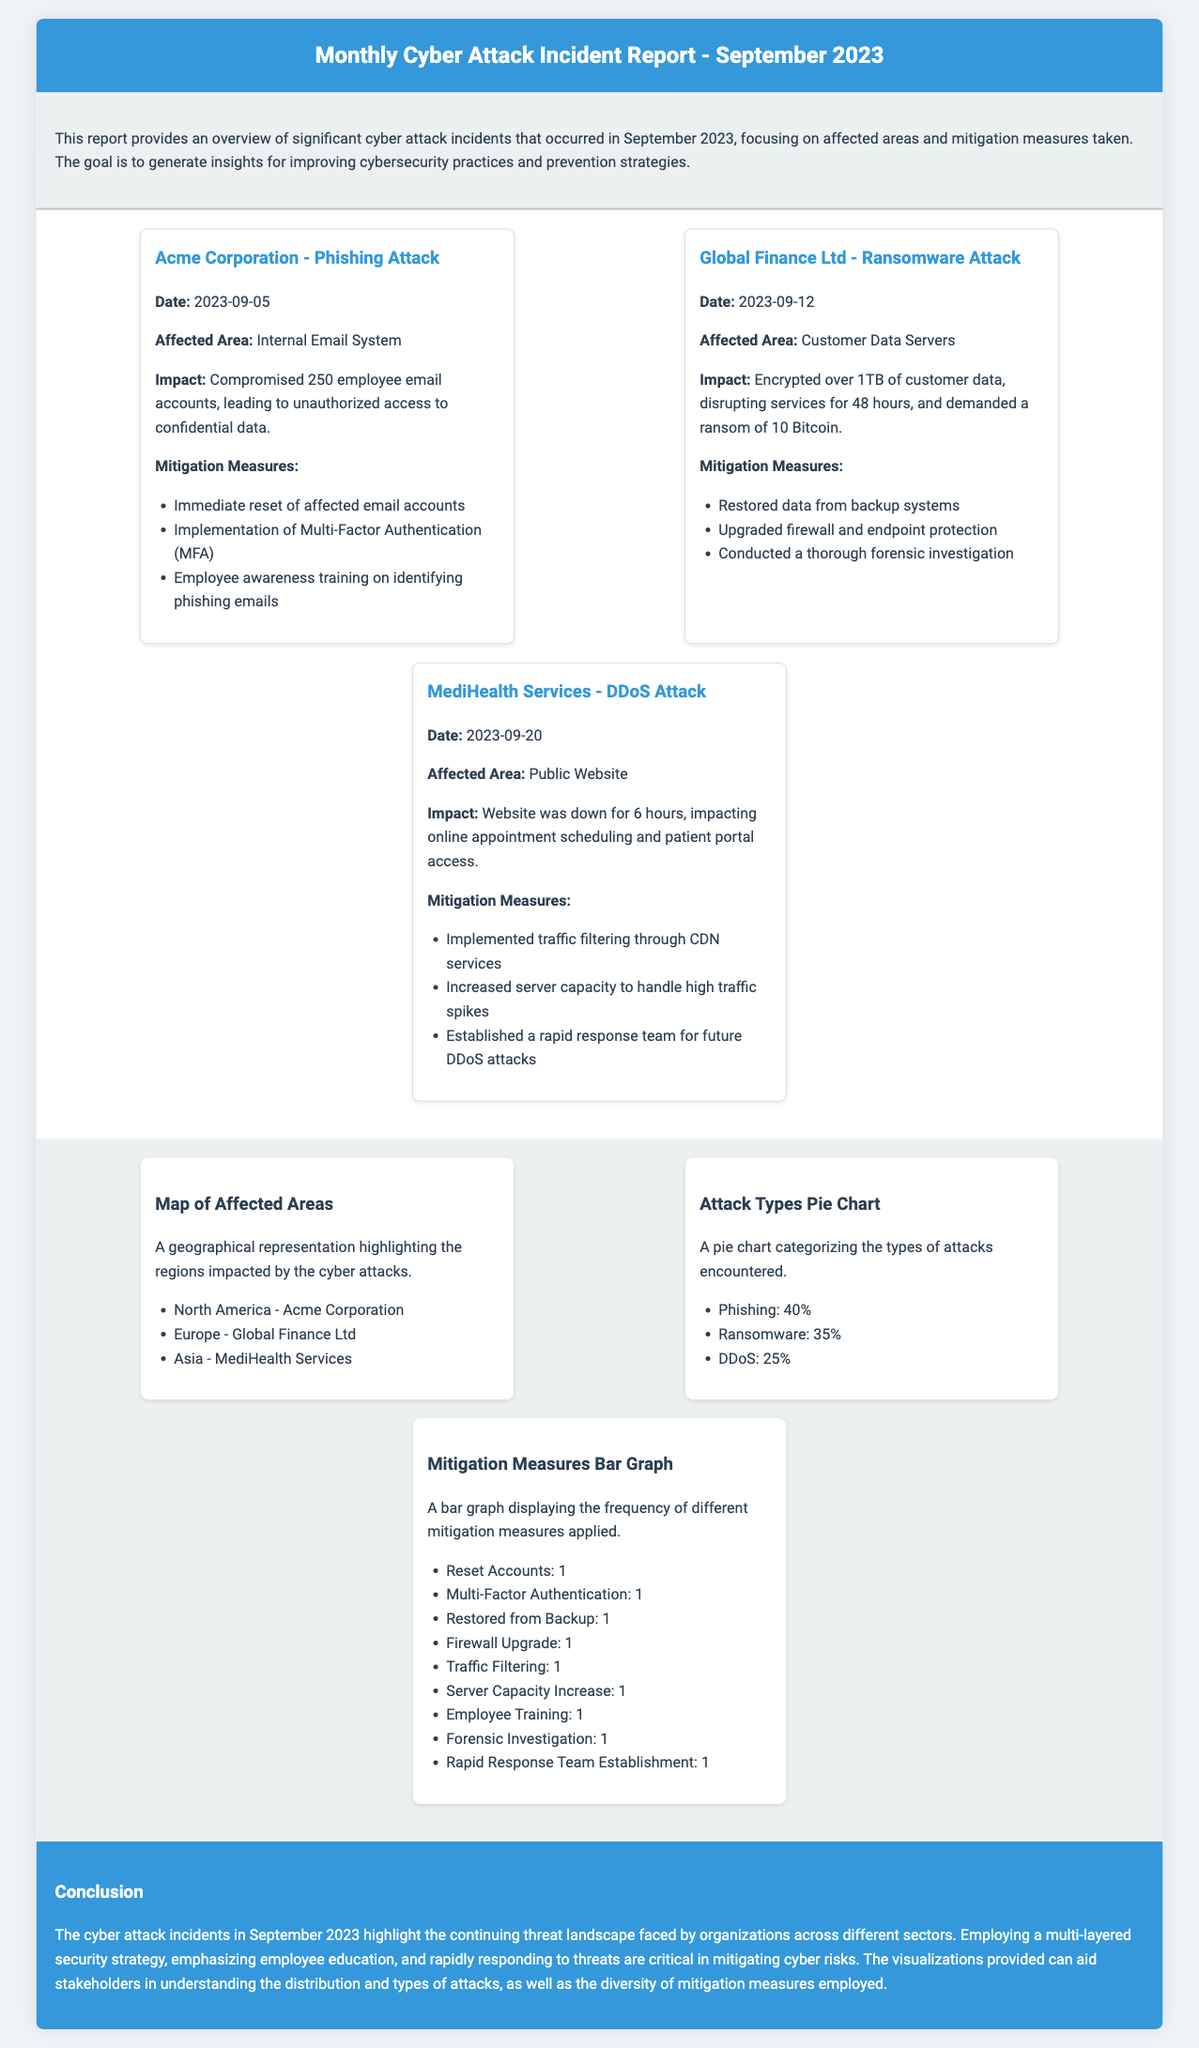What was the date of the phishing attack? The phishing attack occurred on September 5, 2023, as mentioned in the incident details.
Answer: September 5, 2023 How many employee email accounts were compromised in the phishing attack? The report states that 250 employee email accounts were compromised during the phishing attack.
Answer: 250 What type of attack did Global Finance Ltd experience? The document specifies that Global Finance Ltd faced a ransomware attack in September 2023.
Answer: Ransomware Which mitigation measure was common across all incidents? The report highlights that each incident involved some form of account reset as a mitigation measure.
Answer: Reset Accounts How long did the DDoS attack impact the public website? The incident report states that the website was down for 6 hours due to the DDoS attack.
Answer: 6 hours What percentage of attacks were phishing attacks? The pie chart indicates that phishing attacks accounted for 40% of the total incidents.
Answer: 40% Which organization was affected by the DDoS attack? MediHealth Services is identified as the organization affected by the DDoS attack in the incident report.
Answer: MediHealth Services What visualization types are provided in the report? The report includes a map of affected areas, a pie chart for attack types, and a bar graph for mitigation measures.
Answer: Map, Pie Chart, Bar Graph What was the monetary demand in the ransomware attack? The document mentions that a ransom of 10 Bitcoin was demanded in the ransomware attack.
Answer: 10 Bitcoin 